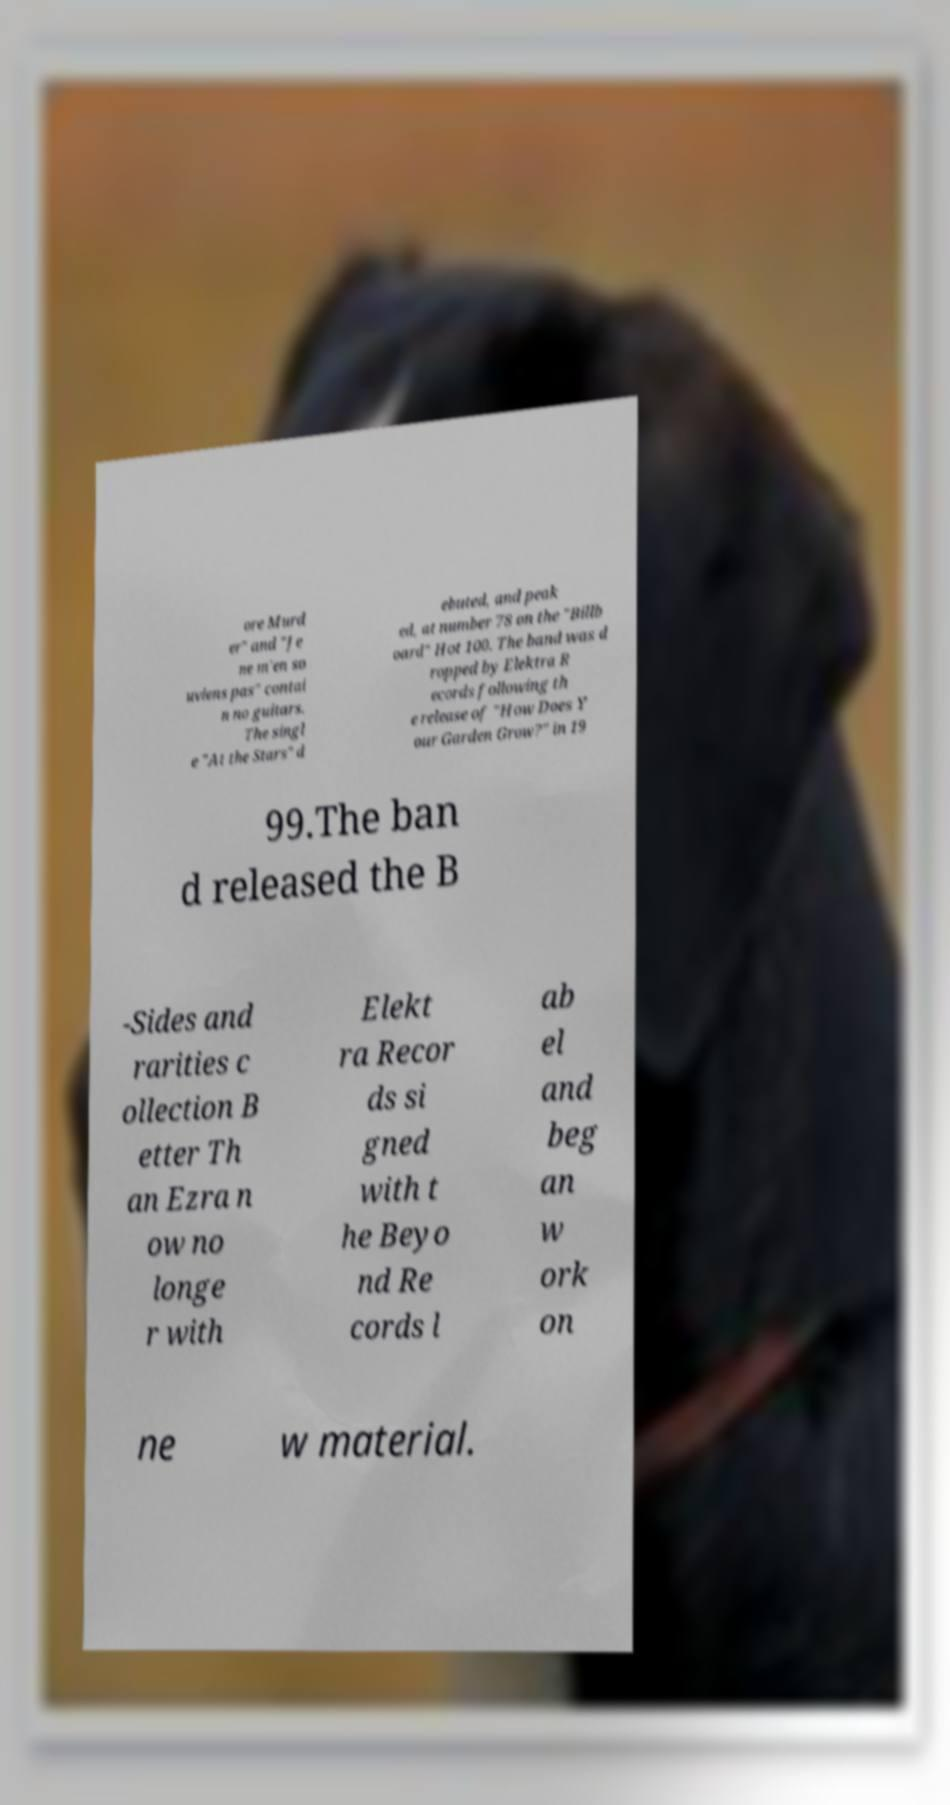What messages or text are displayed in this image? I need them in a readable, typed format. ore Murd er" and "Je ne m'en so uviens pas" contai n no guitars. The singl e "At the Stars" d ebuted, and peak ed, at number 78 on the "Billb oard" Hot 100. The band was d ropped by Elektra R ecords following th e release of "How Does Y our Garden Grow?" in 19 99.The ban d released the B -Sides and rarities c ollection B etter Th an Ezra n ow no longe r with Elekt ra Recor ds si gned with t he Beyo nd Re cords l ab el and beg an w ork on ne w material. 